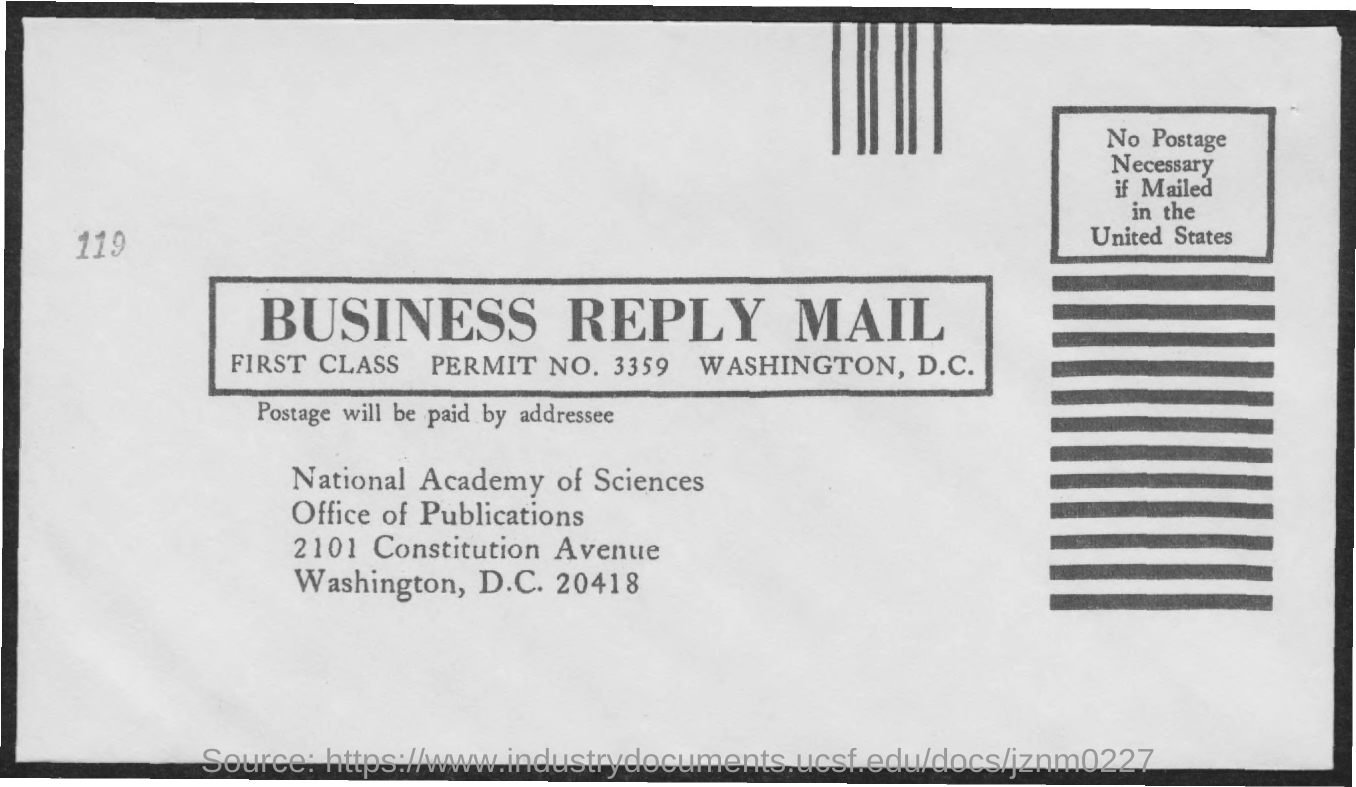What is the type of class mentioned?
Your answer should be very brief. FIRST. What is the permit no. mentioned ?
Provide a short and direct response. 3359. 